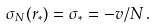Convert formula to latex. <formula><loc_0><loc_0><loc_500><loc_500>\sigma _ { N } ( r _ { * } ) = \sigma _ { * } = - v / N \, .</formula> 